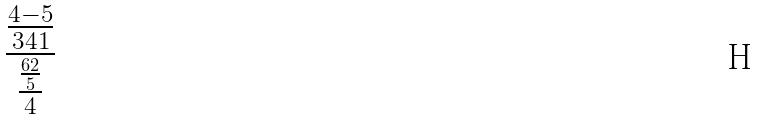<formula> <loc_0><loc_0><loc_500><loc_500>\frac { \frac { 4 - 5 } { 3 4 1 } } { \frac { \frac { 6 2 } { 5 } } { 4 } }</formula> 